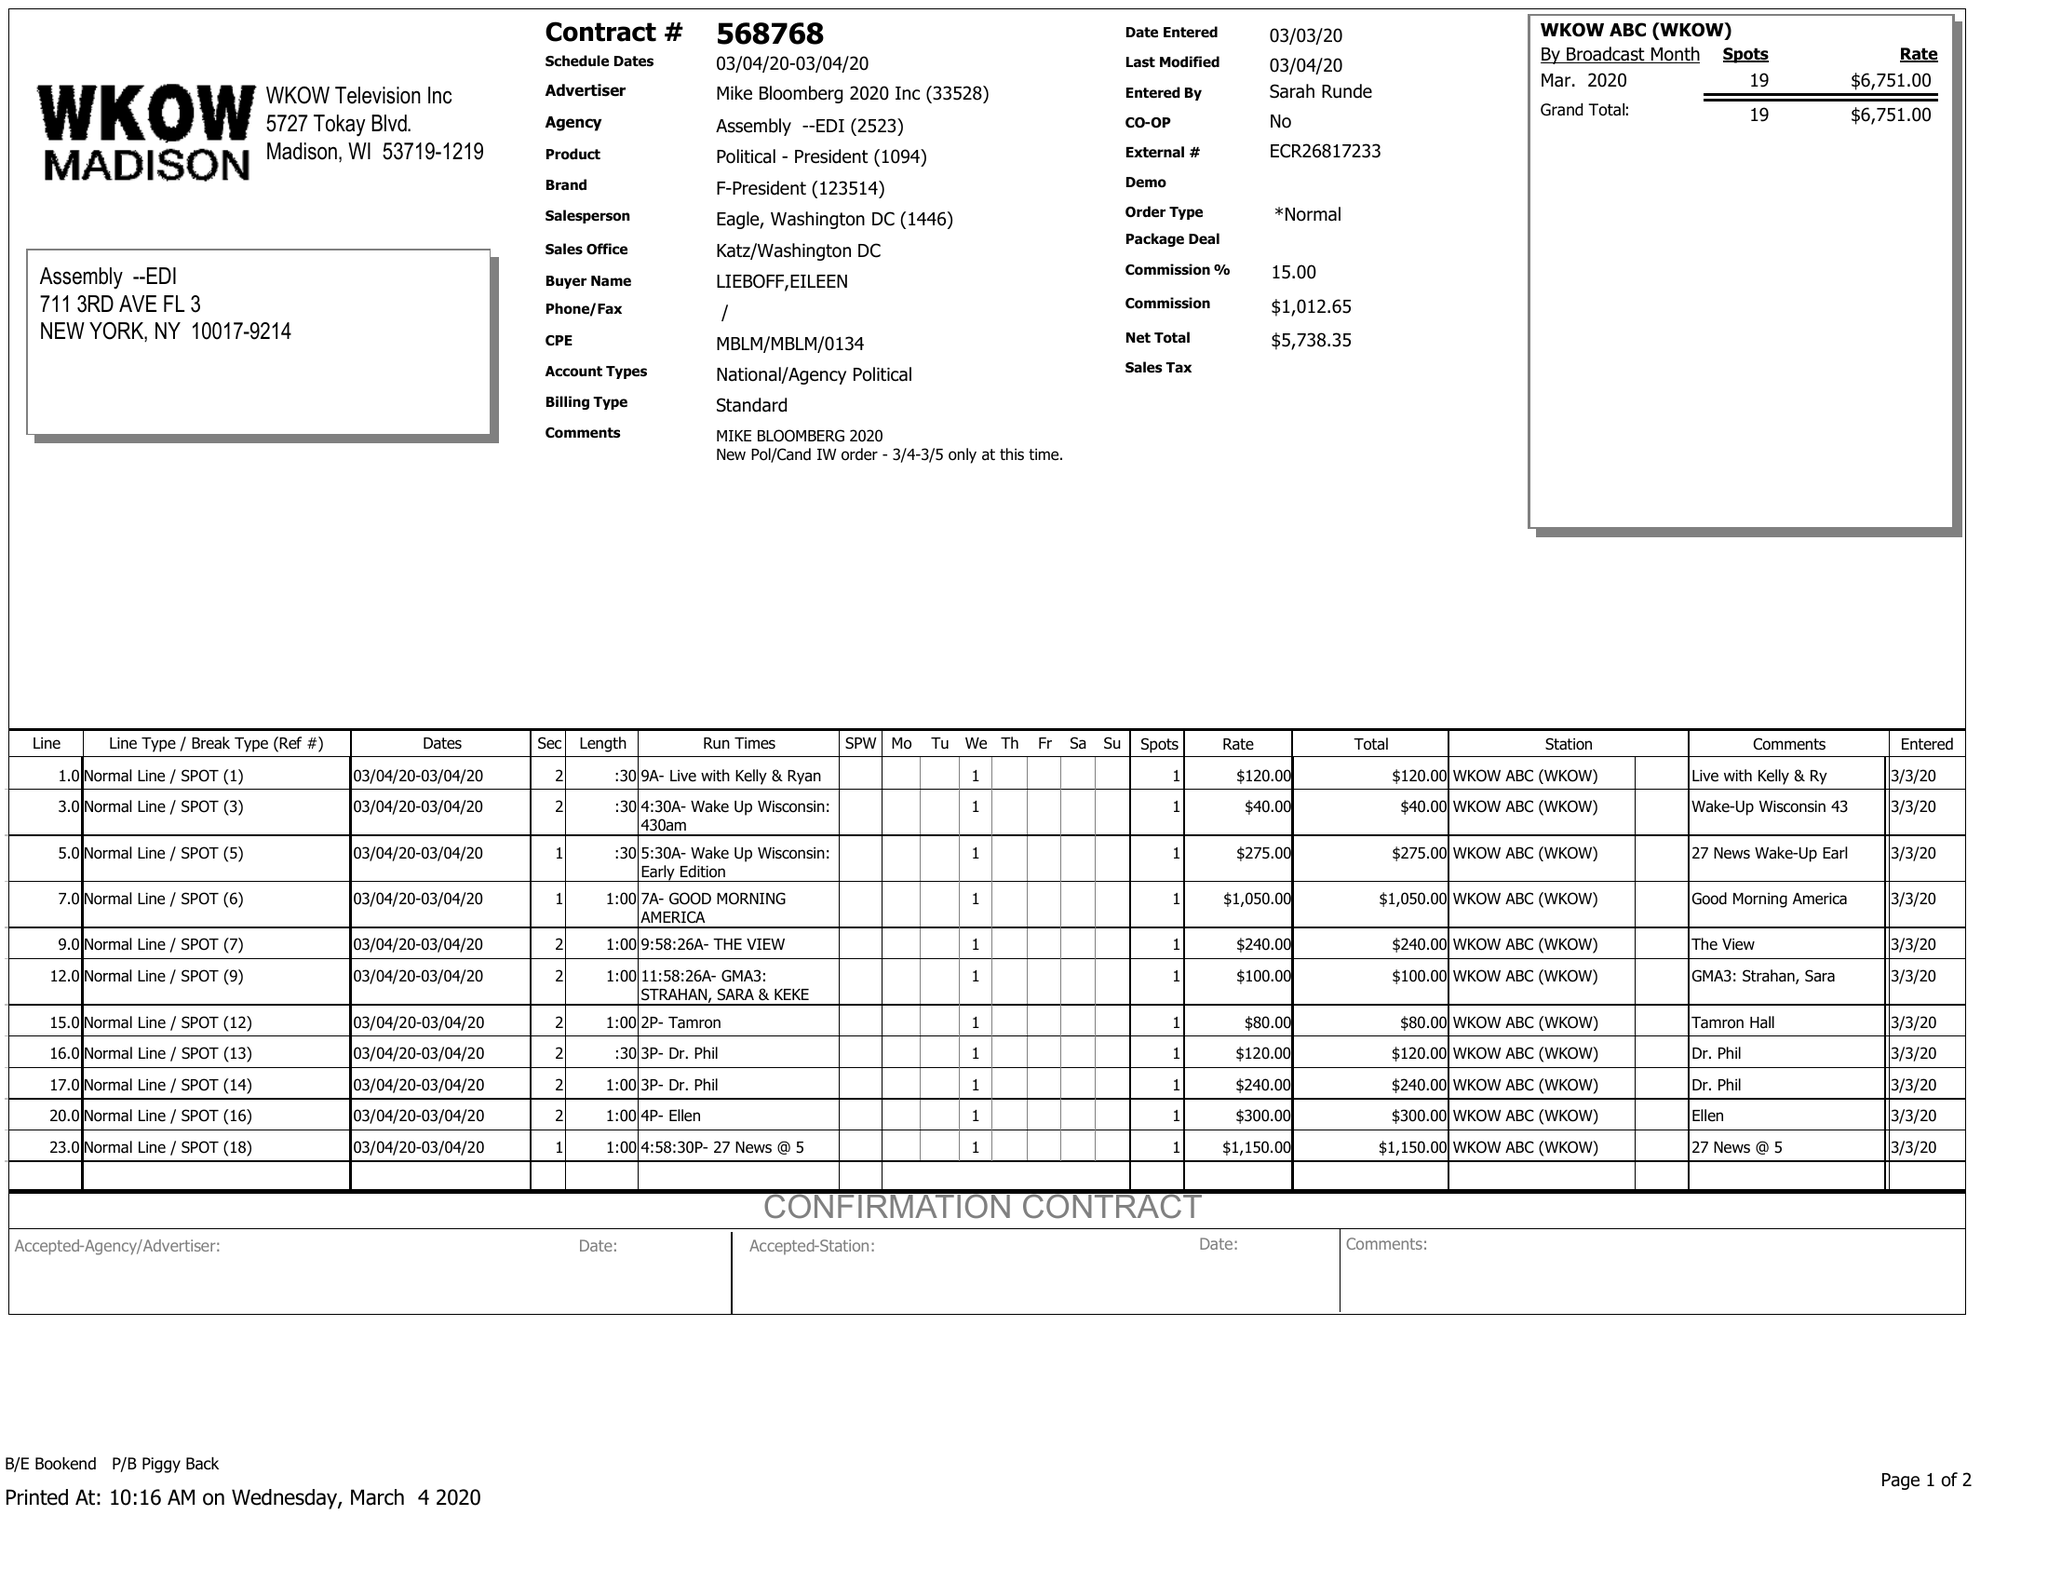What is the value for the flight_from?
Answer the question using a single word or phrase. 03/04/20 